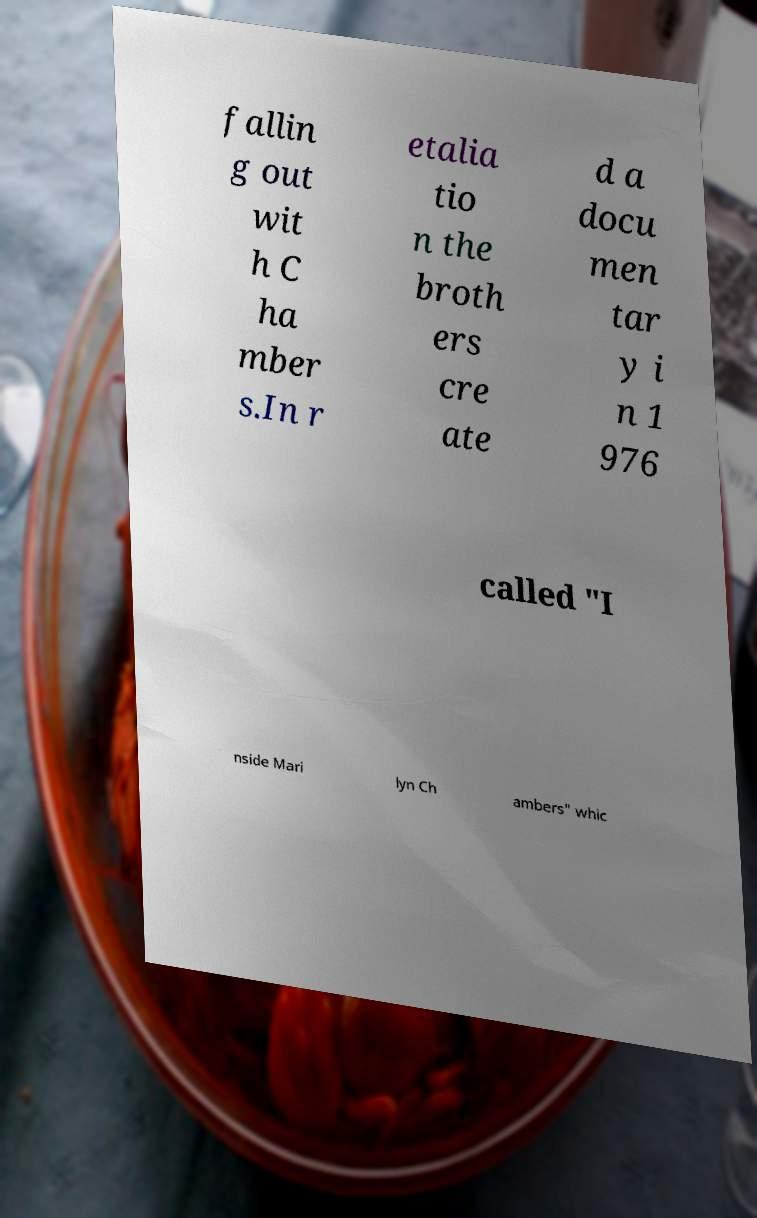What messages or text are displayed in this image? I need them in a readable, typed format. fallin g out wit h C ha mber s.In r etalia tio n the broth ers cre ate d a docu men tar y i n 1 976 called "I nside Mari lyn Ch ambers" whic 